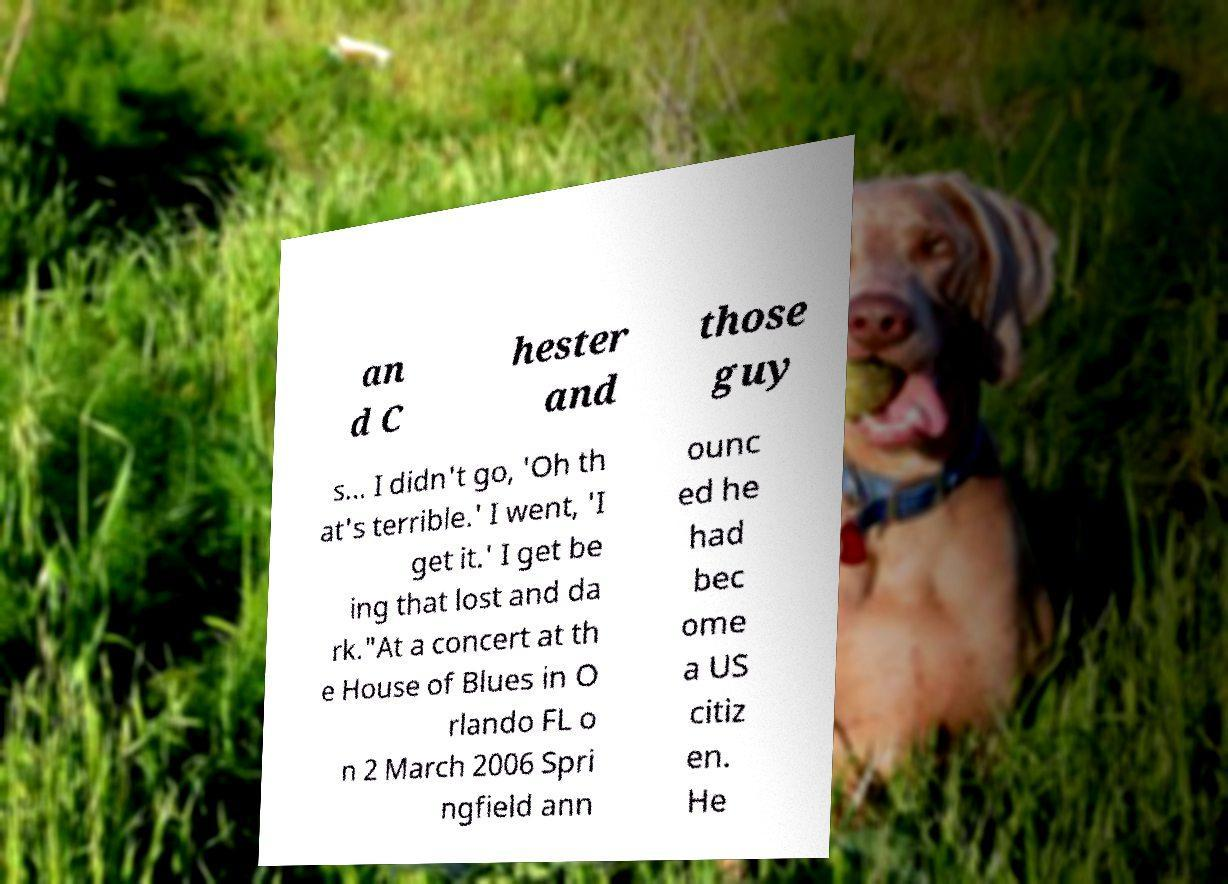For documentation purposes, I need the text within this image transcribed. Could you provide that? an d C hester and those guy s… I didn't go, 'Oh th at's terrible.' I went, 'I get it.' I get be ing that lost and da rk."At a concert at th e House of Blues in O rlando FL o n 2 March 2006 Spri ngfield ann ounc ed he had bec ome a US citiz en. He 